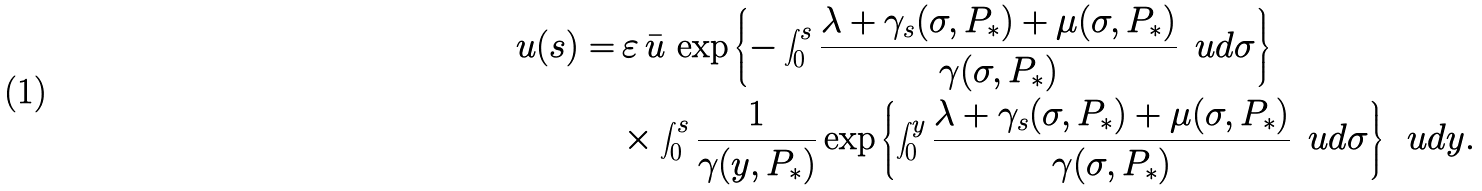<formula> <loc_0><loc_0><loc_500><loc_500>u ( s ) = & \, \varepsilon \, \bar { u } \, \exp \left \{ - \int _ { 0 } ^ { s } \frac { \lambda + \gamma _ { s } ( \sigma , P _ { * } ) + \mu ( \sigma , P _ { * } ) } { \gamma ( \sigma , P _ { * } ) } \, \ u d \sigma \right \} \\ & \times \int _ { 0 } ^ { s } \frac { 1 } { \gamma ( y , P _ { * } ) } \exp \left \{ \int _ { 0 } ^ { y } \frac { \lambda + \gamma _ { s } ( \sigma , P _ { * } ) + \mu ( \sigma , P _ { * } ) } { \gamma ( \sigma , P _ { * } ) } \, \ u d \sigma \right \} \, \ u d y .</formula> 